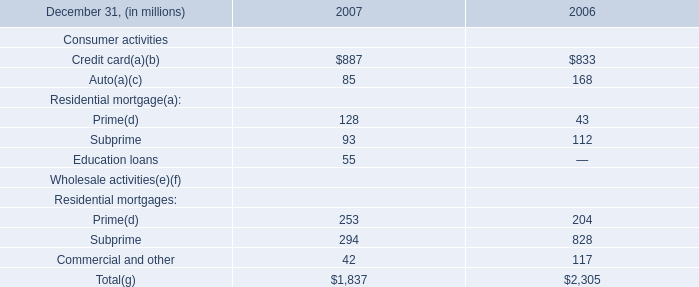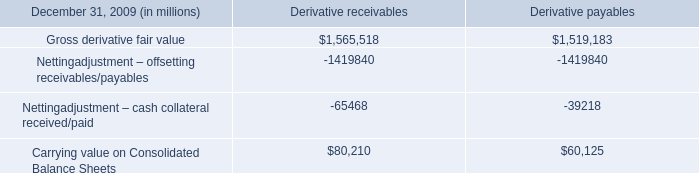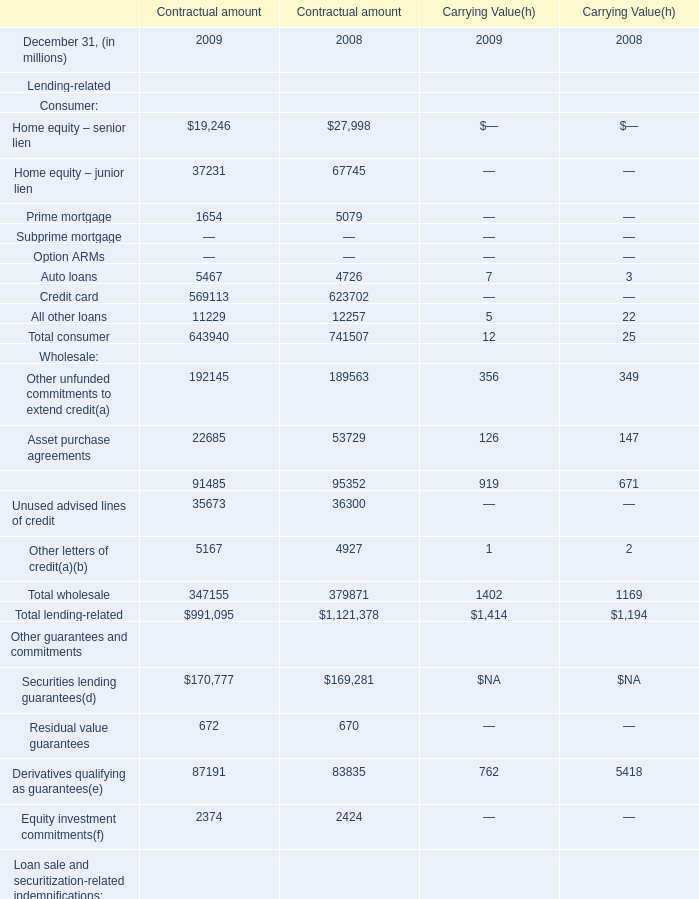What is the average amount of Credit card of Contractual amount 2008, and Carrying value on Consolidated Balance Sheets of Derivative receivables ? 
Computations: ((623702.0 + 80210.0) / 2)
Answer: 351956.0. 